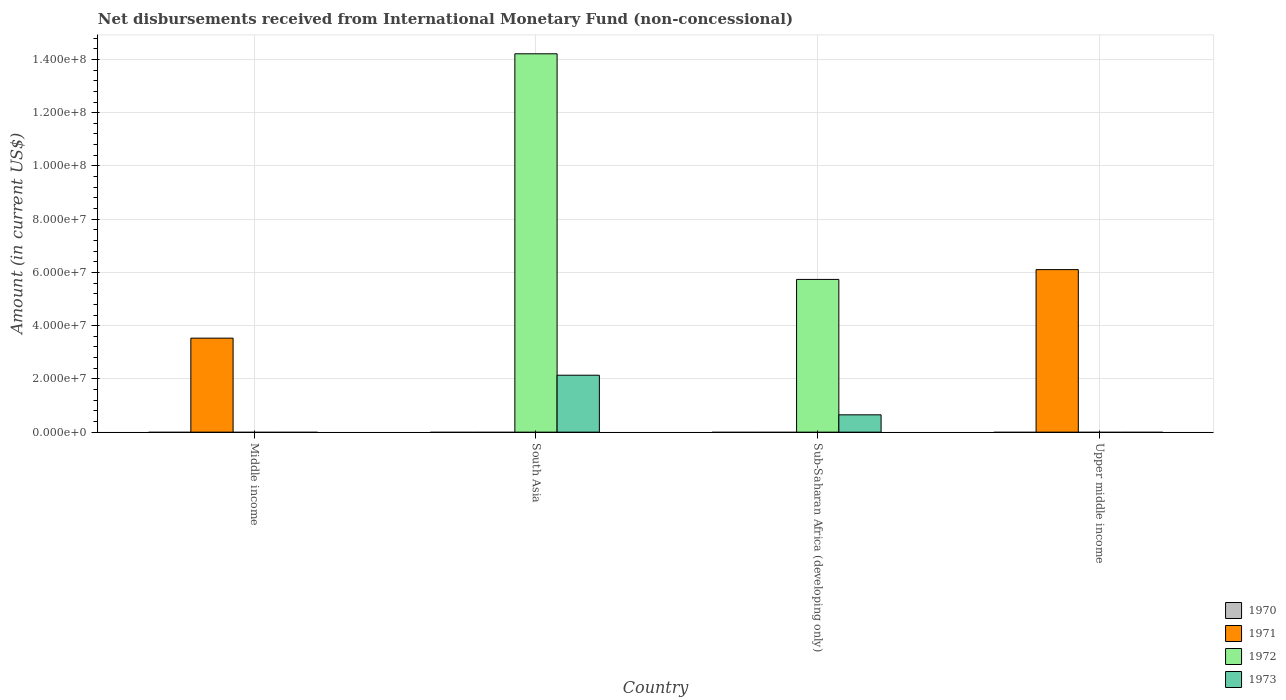How many different coloured bars are there?
Keep it short and to the point. 3. Are the number of bars on each tick of the X-axis equal?
Provide a short and direct response. No. How many bars are there on the 2nd tick from the left?
Your response must be concise. 2. How many bars are there on the 1st tick from the right?
Keep it short and to the point. 1. In how many cases, is the number of bars for a given country not equal to the number of legend labels?
Keep it short and to the point. 4. What is the amount of disbursements received from International Monetary Fund in 1972 in Sub-Saharan Africa (developing only)?
Give a very brief answer. 5.74e+07. Across all countries, what is the maximum amount of disbursements received from International Monetary Fund in 1971?
Give a very brief answer. 6.11e+07. Across all countries, what is the minimum amount of disbursements received from International Monetary Fund in 1970?
Provide a succinct answer. 0. In which country was the amount of disbursements received from International Monetary Fund in 1971 maximum?
Provide a short and direct response. Upper middle income. What is the difference between the amount of disbursements received from International Monetary Fund in 1972 in South Asia and the amount of disbursements received from International Monetary Fund in 1971 in Upper middle income?
Provide a succinct answer. 8.11e+07. What is the difference between the amount of disbursements received from International Monetary Fund of/in 1972 and amount of disbursements received from International Monetary Fund of/in 1973 in Sub-Saharan Africa (developing only)?
Give a very brief answer. 5.09e+07. In how many countries, is the amount of disbursements received from International Monetary Fund in 1970 greater than 12000000 US$?
Offer a very short reply. 0. What is the difference between the highest and the lowest amount of disbursements received from International Monetary Fund in 1973?
Offer a terse response. 2.14e+07. Is it the case that in every country, the sum of the amount of disbursements received from International Monetary Fund in 1970 and amount of disbursements received from International Monetary Fund in 1973 is greater than the sum of amount of disbursements received from International Monetary Fund in 1972 and amount of disbursements received from International Monetary Fund in 1971?
Keep it short and to the point. No. How many countries are there in the graph?
Your answer should be compact. 4. What is the difference between two consecutive major ticks on the Y-axis?
Provide a succinct answer. 2.00e+07. Does the graph contain any zero values?
Make the answer very short. Yes. Where does the legend appear in the graph?
Your response must be concise. Bottom right. What is the title of the graph?
Ensure brevity in your answer.  Net disbursements received from International Monetary Fund (non-concessional). Does "1983" appear as one of the legend labels in the graph?
Provide a short and direct response. No. What is the Amount (in current US$) in 1970 in Middle income?
Your answer should be very brief. 0. What is the Amount (in current US$) in 1971 in Middle income?
Ensure brevity in your answer.  3.53e+07. What is the Amount (in current US$) of 1971 in South Asia?
Provide a succinct answer. 0. What is the Amount (in current US$) of 1972 in South Asia?
Your answer should be compact. 1.42e+08. What is the Amount (in current US$) of 1973 in South Asia?
Provide a short and direct response. 2.14e+07. What is the Amount (in current US$) in 1970 in Sub-Saharan Africa (developing only)?
Ensure brevity in your answer.  0. What is the Amount (in current US$) in 1971 in Sub-Saharan Africa (developing only)?
Offer a very short reply. 0. What is the Amount (in current US$) of 1972 in Sub-Saharan Africa (developing only)?
Provide a succinct answer. 5.74e+07. What is the Amount (in current US$) of 1973 in Sub-Saharan Africa (developing only)?
Provide a succinct answer. 6.51e+06. What is the Amount (in current US$) of 1970 in Upper middle income?
Give a very brief answer. 0. What is the Amount (in current US$) in 1971 in Upper middle income?
Provide a short and direct response. 6.11e+07. What is the Amount (in current US$) in 1973 in Upper middle income?
Offer a very short reply. 0. Across all countries, what is the maximum Amount (in current US$) of 1971?
Offer a very short reply. 6.11e+07. Across all countries, what is the maximum Amount (in current US$) of 1972?
Make the answer very short. 1.42e+08. Across all countries, what is the maximum Amount (in current US$) of 1973?
Provide a succinct answer. 2.14e+07. What is the total Amount (in current US$) of 1971 in the graph?
Ensure brevity in your answer.  9.64e+07. What is the total Amount (in current US$) of 1972 in the graph?
Provide a succinct answer. 2.00e+08. What is the total Amount (in current US$) of 1973 in the graph?
Keep it short and to the point. 2.79e+07. What is the difference between the Amount (in current US$) of 1971 in Middle income and that in Upper middle income?
Offer a very short reply. -2.57e+07. What is the difference between the Amount (in current US$) of 1972 in South Asia and that in Sub-Saharan Africa (developing only)?
Your response must be concise. 8.48e+07. What is the difference between the Amount (in current US$) of 1973 in South Asia and that in Sub-Saharan Africa (developing only)?
Provide a short and direct response. 1.49e+07. What is the difference between the Amount (in current US$) of 1971 in Middle income and the Amount (in current US$) of 1972 in South Asia?
Provide a short and direct response. -1.07e+08. What is the difference between the Amount (in current US$) of 1971 in Middle income and the Amount (in current US$) of 1973 in South Asia?
Offer a very short reply. 1.39e+07. What is the difference between the Amount (in current US$) of 1971 in Middle income and the Amount (in current US$) of 1972 in Sub-Saharan Africa (developing only)?
Your answer should be compact. -2.21e+07. What is the difference between the Amount (in current US$) of 1971 in Middle income and the Amount (in current US$) of 1973 in Sub-Saharan Africa (developing only)?
Give a very brief answer. 2.88e+07. What is the difference between the Amount (in current US$) of 1972 in South Asia and the Amount (in current US$) of 1973 in Sub-Saharan Africa (developing only)?
Ensure brevity in your answer.  1.36e+08. What is the average Amount (in current US$) in 1970 per country?
Your response must be concise. 0. What is the average Amount (in current US$) in 1971 per country?
Keep it short and to the point. 2.41e+07. What is the average Amount (in current US$) in 1972 per country?
Keep it short and to the point. 4.99e+07. What is the average Amount (in current US$) in 1973 per country?
Provide a short and direct response. 6.98e+06. What is the difference between the Amount (in current US$) in 1972 and Amount (in current US$) in 1973 in South Asia?
Give a very brief answer. 1.21e+08. What is the difference between the Amount (in current US$) of 1972 and Amount (in current US$) of 1973 in Sub-Saharan Africa (developing only)?
Provide a succinct answer. 5.09e+07. What is the ratio of the Amount (in current US$) in 1971 in Middle income to that in Upper middle income?
Give a very brief answer. 0.58. What is the ratio of the Amount (in current US$) of 1972 in South Asia to that in Sub-Saharan Africa (developing only)?
Provide a succinct answer. 2.48. What is the ratio of the Amount (in current US$) in 1973 in South Asia to that in Sub-Saharan Africa (developing only)?
Keep it short and to the point. 3.29. What is the difference between the highest and the lowest Amount (in current US$) in 1971?
Give a very brief answer. 6.11e+07. What is the difference between the highest and the lowest Amount (in current US$) in 1972?
Offer a very short reply. 1.42e+08. What is the difference between the highest and the lowest Amount (in current US$) of 1973?
Provide a short and direct response. 2.14e+07. 